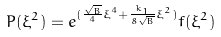Convert formula to latex. <formula><loc_0><loc_0><loc_500><loc_500>P ( \xi ^ { 2 } ) = e ^ { ( \frac { \sqrt { B } } { 4 } \xi ^ { 4 } + \frac { k _ { 1 } } { 8 \sqrt { B } } \xi ^ { 2 } ) } f ( \xi ^ { 2 } )</formula> 